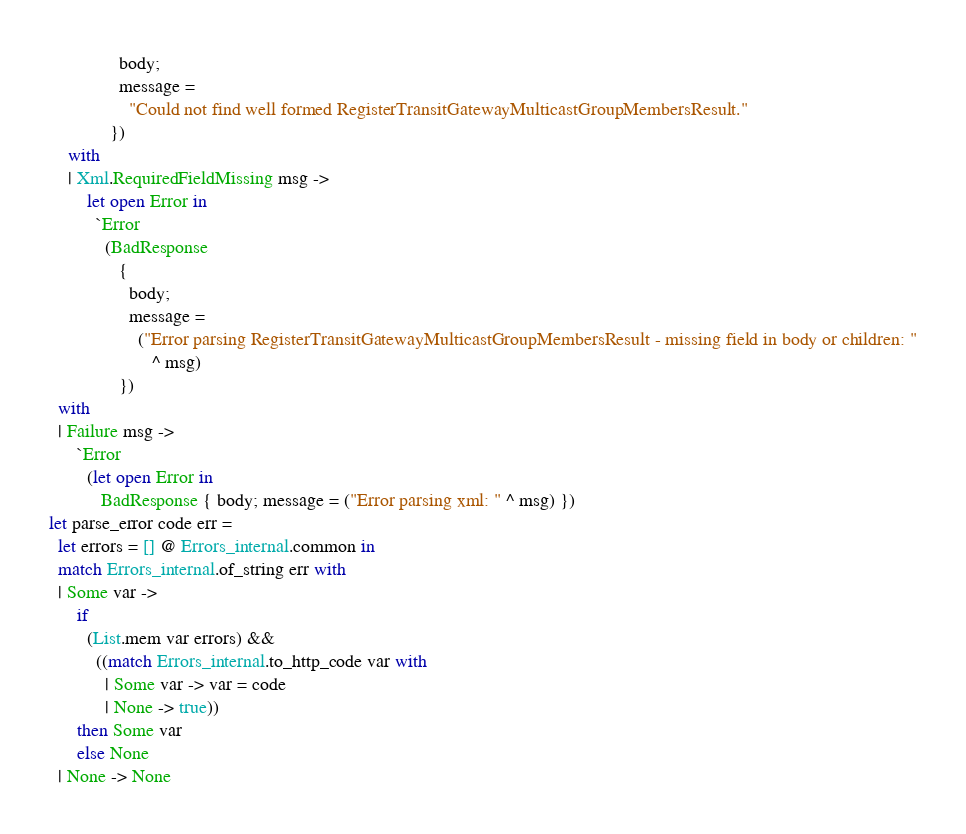Convert code to text. <code><loc_0><loc_0><loc_500><loc_500><_OCaml_>               body;
               message =
                 "Could not find well formed RegisterTransitGatewayMulticastGroupMembersResult."
             })
    with
    | Xml.RequiredFieldMissing msg ->
        let open Error in
          `Error
            (BadResponse
               {
                 body;
                 message =
                   ("Error parsing RegisterTransitGatewayMulticastGroupMembersResult - missing field in body or children: "
                      ^ msg)
               })
  with
  | Failure msg ->
      `Error
        (let open Error in
           BadResponse { body; message = ("Error parsing xml: " ^ msg) })
let parse_error code err =
  let errors = [] @ Errors_internal.common in
  match Errors_internal.of_string err with
  | Some var ->
      if
        (List.mem var errors) &&
          ((match Errors_internal.to_http_code var with
            | Some var -> var = code
            | None -> true))
      then Some var
      else None
  | None -> None</code> 